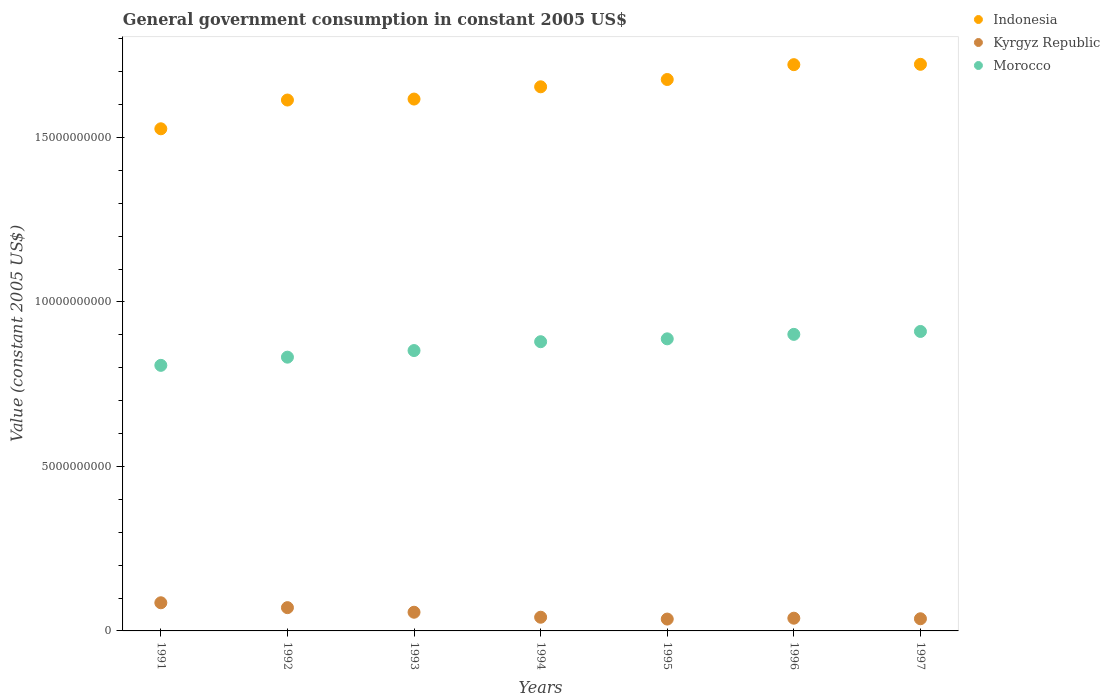What is the government conusmption in Indonesia in 1994?
Your answer should be very brief. 1.65e+1. Across all years, what is the maximum government conusmption in Indonesia?
Your answer should be very brief. 1.72e+1. Across all years, what is the minimum government conusmption in Morocco?
Give a very brief answer. 8.07e+09. In which year was the government conusmption in Indonesia minimum?
Offer a terse response. 1991. What is the total government conusmption in Indonesia in the graph?
Give a very brief answer. 1.15e+11. What is the difference between the government conusmption in Indonesia in 1991 and that in 1997?
Ensure brevity in your answer.  -1.96e+09. What is the difference between the government conusmption in Kyrgyz Republic in 1991 and the government conusmption in Morocco in 1992?
Your response must be concise. -7.47e+09. What is the average government conusmption in Morocco per year?
Your response must be concise. 8.67e+09. In the year 1991, what is the difference between the government conusmption in Indonesia and government conusmption in Morocco?
Your answer should be very brief. 7.19e+09. In how many years, is the government conusmption in Kyrgyz Republic greater than 10000000000 US$?
Your response must be concise. 0. What is the ratio of the government conusmption in Indonesia in 1994 to that in 1996?
Make the answer very short. 0.96. Is the government conusmption in Kyrgyz Republic in 1994 less than that in 1995?
Make the answer very short. No. What is the difference between the highest and the second highest government conusmption in Indonesia?
Your answer should be compact. 1.05e+07. What is the difference between the highest and the lowest government conusmption in Morocco?
Your response must be concise. 1.03e+09. Is the government conusmption in Morocco strictly greater than the government conusmption in Kyrgyz Republic over the years?
Give a very brief answer. Yes. How many years are there in the graph?
Make the answer very short. 7. What is the difference between two consecutive major ticks on the Y-axis?
Your response must be concise. 5.00e+09. Does the graph contain any zero values?
Provide a short and direct response. No. Where does the legend appear in the graph?
Make the answer very short. Top right. What is the title of the graph?
Ensure brevity in your answer.  General government consumption in constant 2005 US$. What is the label or title of the Y-axis?
Your answer should be compact. Value (constant 2005 US$). What is the Value (constant 2005 US$) of Indonesia in 1991?
Keep it short and to the point. 1.53e+1. What is the Value (constant 2005 US$) of Kyrgyz Republic in 1991?
Make the answer very short. 8.56e+08. What is the Value (constant 2005 US$) in Morocco in 1991?
Offer a terse response. 8.07e+09. What is the Value (constant 2005 US$) of Indonesia in 1992?
Your response must be concise. 1.61e+1. What is the Value (constant 2005 US$) of Kyrgyz Republic in 1992?
Ensure brevity in your answer.  7.08e+08. What is the Value (constant 2005 US$) in Morocco in 1992?
Offer a very short reply. 8.32e+09. What is the Value (constant 2005 US$) of Indonesia in 1993?
Your answer should be compact. 1.62e+1. What is the Value (constant 2005 US$) of Kyrgyz Republic in 1993?
Your answer should be very brief. 5.68e+08. What is the Value (constant 2005 US$) of Morocco in 1993?
Keep it short and to the point. 8.52e+09. What is the Value (constant 2005 US$) of Indonesia in 1994?
Offer a terse response. 1.65e+1. What is the Value (constant 2005 US$) in Kyrgyz Republic in 1994?
Provide a succinct answer. 4.16e+08. What is the Value (constant 2005 US$) in Morocco in 1994?
Ensure brevity in your answer.  8.79e+09. What is the Value (constant 2005 US$) of Indonesia in 1995?
Ensure brevity in your answer.  1.68e+1. What is the Value (constant 2005 US$) of Kyrgyz Republic in 1995?
Give a very brief answer. 3.60e+08. What is the Value (constant 2005 US$) in Morocco in 1995?
Your response must be concise. 8.88e+09. What is the Value (constant 2005 US$) of Indonesia in 1996?
Give a very brief answer. 1.72e+1. What is the Value (constant 2005 US$) of Kyrgyz Republic in 1996?
Provide a short and direct response. 3.87e+08. What is the Value (constant 2005 US$) of Morocco in 1996?
Ensure brevity in your answer.  9.02e+09. What is the Value (constant 2005 US$) in Indonesia in 1997?
Provide a succinct answer. 1.72e+1. What is the Value (constant 2005 US$) in Kyrgyz Republic in 1997?
Give a very brief answer. 3.70e+08. What is the Value (constant 2005 US$) in Morocco in 1997?
Your answer should be compact. 9.10e+09. Across all years, what is the maximum Value (constant 2005 US$) of Indonesia?
Your answer should be compact. 1.72e+1. Across all years, what is the maximum Value (constant 2005 US$) of Kyrgyz Republic?
Ensure brevity in your answer.  8.56e+08. Across all years, what is the maximum Value (constant 2005 US$) of Morocco?
Provide a succinct answer. 9.10e+09. Across all years, what is the minimum Value (constant 2005 US$) of Indonesia?
Make the answer very short. 1.53e+1. Across all years, what is the minimum Value (constant 2005 US$) in Kyrgyz Republic?
Provide a succinct answer. 3.60e+08. Across all years, what is the minimum Value (constant 2005 US$) in Morocco?
Your response must be concise. 8.07e+09. What is the total Value (constant 2005 US$) of Indonesia in the graph?
Make the answer very short. 1.15e+11. What is the total Value (constant 2005 US$) in Kyrgyz Republic in the graph?
Make the answer very short. 3.66e+09. What is the total Value (constant 2005 US$) of Morocco in the graph?
Give a very brief answer. 6.07e+1. What is the difference between the Value (constant 2005 US$) of Indonesia in 1991 and that in 1992?
Give a very brief answer. -8.74e+08. What is the difference between the Value (constant 2005 US$) of Kyrgyz Republic in 1991 and that in 1992?
Your answer should be compact. 1.48e+08. What is the difference between the Value (constant 2005 US$) in Morocco in 1991 and that in 1992?
Your response must be concise. -2.49e+08. What is the difference between the Value (constant 2005 US$) of Indonesia in 1991 and that in 1993?
Your answer should be compact. -9.04e+08. What is the difference between the Value (constant 2005 US$) in Kyrgyz Republic in 1991 and that in 1993?
Ensure brevity in your answer.  2.88e+08. What is the difference between the Value (constant 2005 US$) of Morocco in 1991 and that in 1993?
Provide a short and direct response. -4.50e+08. What is the difference between the Value (constant 2005 US$) of Indonesia in 1991 and that in 1994?
Keep it short and to the point. -1.28e+09. What is the difference between the Value (constant 2005 US$) in Kyrgyz Republic in 1991 and that in 1994?
Provide a succinct answer. 4.40e+08. What is the difference between the Value (constant 2005 US$) of Morocco in 1991 and that in 1994?
Ensure brevity in your answer.  -7.19e+08. What is the difference between the Value (constant 2005 US$) in Indonesia in 1991 and that in 1995?
Keep it short and to the point. -1.50e+09. What is the difference between the Value (constant 2005 US$) in Kyrgyz Republic in 1991 and that in 1995?
Your answer should be compact. 4.95e+08. What is the difference between the Value (constant 2005 US$) of Morocco in 1991 and that in 1995?
Offer a terse response. -8.06e+08. What is the difference between the Value (constant 2005 US$) of Indonesia in 1991 and that in 1996?
Keep it short and to the point. -1.95e+09. What is the difference between the Value (constant 2005 US$) of Kyrgyz Republic in 1991 and that in 1996?
Provide a succinct answer. 4.69e+08. What is the difference between the Value (constant 2005 US$) in Morocco in 1991 and that in 1996?
Provide a short and direct response. -9.42e+08. What is the difference between the Value (constant 2005 US$) of Indonesia in 1991 and that in 1997?
Your answer should be very brief. -1.96e+09. What is the difference between the Value (constant 2005 US$) in Kyrgyz Republic in 1991 and that in 1997?
Your answer should be very brief. 4.86e+08. What is the difference between the Value (constant 2005 US$) of Morocco in 1991 and that in 1997?
Make the answer very short. -1.03e+09. What is the difference between the Value (constant 2005 US$) in Indonesia in 1992 and that in 1993?
Make the answer very short. -2.95e+07. What is the difference between the Value (constant 2005 US$) in Kyrgyz Republic in 1992 and that in 1993?
Ensure brevity in your answer.  1.39e+08. What is the difference between the Value (constant 2005 US$) of Morocco in 1992 and that in 1993?
Offer a terse response. -2.01e+08. What is the difference between the Value (constant 2005 US$) in Indonesia in 1992 and that in 1994?
Keep it short and to the point. -4.02e+08. What is the difference between the Value (constant 2005 US$) in Kyrgyz Republic in 1992 and that in 1994?
Provide a short and direct response. 2.91e+08. What is the difference between the Value (constant 2005 US$) in Morocco in 1992 and that in 1994?
Make the answer very short. -4.70e+08. What is the difference between the Value (constant 2005 US$) in Indonesia in 1992 and that in 1995?
Keep it short and to the point. -6.24e+08. What is the difference between the Value (constant 2005 US$) in Kyrgyz Republic in 1992 and that in 1995?
Ensure brevity in your answer.  3.47e+08. What is the difference between the Value (constant 2005 US$) of Morocco in 1992 and that in 1995?
Your answer should be compact. -5.57e+08. What is the difference between the Value (constant 2005 US$) in Indonesia in 1992 and that in 1996?
Provide a short and direct response. -1.08e+09. What is the difference between the Value (constant 2005 US$) in Kyrgyz Republic in 1992 and that in 1996?
Give a very brief answer. 3.21e+08. What is the difference between the Value (constant 2005 US$) of Morocco in 1992 and that in 1996?
Make the answer very short. -6.93e+08. What is the difference between the Value (constant 2005 US$) of Indonesia in 1992 and that in 1997?
Make the answer very short. -1.09e+09. What is the difference between the Value (constant 2005 US$) in Kyrgyz Republic in 1992 and that in 1997?
Offer a very short reply. 3.38e+08. What is the difference between the Value (constant 2005 US$) of Morocco in 1992 and that in 1997?
Your answer should be compact. -7.82e+08. What is the difference between the Value (constant 2005 US$) of Indonesia in 1993 and that in 1994?
Provide a short and direct response. -3.73e+08. What is the difference between the Value (constant 2005 US$) of Kyrgyz Republic in 1993 and that in 1994?
Your response must be concise. 1.52e+08. What is the difference between the Value (constant 2005 US$) in Morocco in 1993 and that in 1994?
Ensure brevity in your answer.  -2.69e+08. What is the difference between the Value (constant 2005 US$) of Indonesia in 1993 and that in 1995?
Keep it short and to the point. -5.95e+08. What is the difference between the Value (constant 2005 US$) in Kyrgyz Republic in 1993 and that in 1995?
Provide a short and direct response. 2.08e+08. What is the difference between the Value (constant 2005 US$) in Morocco in 1993 and that in 1995?
Offer a terse response. -3.56e+08. What is the difference between the Value (constant 2005 US$) in Indonesia in 1993 and that in 1996?
Keep it short and to the point. -1.05e+09. What is the difference between the Value (constant 2005 US$) in Kyrgyz Republic in 1993 and that in 1996?
Your answer should be very brief. 1.81e+08. What is the difference between the Value (constant 2005 US$) in Morocco in 1993 and that in 1996?
Your answer should be very brief. -4.92e+08. What is the difference between the Value (constant 2005 US$) of Indonesia in 1993 and that in 1997?
Make the answer very short. -1.06e+09. What is the difference between the Value (constant 2005 US$) of Kyrgyz Republic in 1993 and that in 1997?
Ensure brevity in your answer.  1.99e+08. What is the difference between the Value (constant 2005 US$) in Morocco in 1993 and that in 1997?
Give a very brief answer. -5.81e+08. What is the difference between the Value (constant 2005 US$) in Indonesia in 1994 and that in 1995?
Your answer should be very brief. -2.22e+08. What is the difference between the Value (constant 2005 US$) in Kyrgyz Republic in 1994 and that in 1995?
Ensure brevity in your answer.  5.59e+07. What is the difference between the Value (constant 2005 US$) in Morocco in 1994 and that in 1995?
Provide a short and direct response. -8.72e+07. What is the difference between the Value (constant 2005 US$) of Indonesia in 1994 and that in 1996?
Ensure brevity in your answer.  -6.73e+08. What is the difference between the Value (constant 2005 US$) of Kyrgyz Republic in 1994 and that in 1996?
Keep it short and to the point. 2.95e+07. What is the difference between the Value (constant 2005 US$) of Morocco in 1994 and that in 1996?
Make the answer very short. -2.23e+08. What is the difference between the Value (constant 2005 US$) in Indonesia in 1994 and that in 1997?
Your answer should be very brief. -6.84e+08. What is the difference between the Value (constant 2005 US$) in Kyrgyz Republic in 1994 and that in 1997?
Give a very brief answer. 4.68e+07. What is the difference between the Value (constant 2005 US$) in Morocco in 1994 and that in 1997?
Offer a very short reply. -3.12e+08. What is the difference between the Value (constant 2005 US$) of Indonesia in 1995 and that in 1996?
Your answer should be very brief. -4.51e+08. What is the difference between the Value (constant 2005 US$) of Kyrgyz Republic in 1995 and that in 1996?
Ensure brevity in your answer.  -2.63e+07. What is the difference between the Value (constant 2005 US$) in Morocco in 1995 and that in 1996?
Ensure brevity in your answer.  -1.36e+08. What is the difference between the Value (constant 2005 US$) of Indonesia in 1995 and that in 1997?
Your answer should be very brief. -4.62e+08. What is the difference between the Value (constant 2005 US$) of Kyrgyz Republic in 1995 and that in 1997?
Provide a short and direct response. -9.12e+06. What is the difference between the Value (constant 2005 US$) of Morocco in 1995 and that in 1997?
Ensure brevity in your answer.  -2.24e+08. What is the difference between the Value (constant 2005 US$) in Indonesia in 1996 and that in 1997?
Offer a very short reply. -1.05e+07. What is the difference between the Value (constant 2005 US$) of Kyrgyz Republic in 1996 and that in 1997?
Ensure brevity in your answer.  1.72e+07. What is the difference between the Value (constant 2005 US$) in Morocco in 1996 and that in 1997?
Offer a very short reply. -8.85e+07. What is the difference between the Value (constant 2005 US$) in Indonesia in 1991 and the Value (constant 2005 US$) in Kyrgyz Republic in 1992?
Offer a terse response. 1.46e+1. What is the difference between the Value (constant 2005 US$) of Indonesia in 1991 and the Value (constant 2005 US$) of Morocco in 1992?
Give a very brief answer. 6.94e+09. What is the difference between the Value (constant 2005 US$) in Kyrgyz Republic in 1991 and the Value (constant 2005 US$) in Morocco in 1992?
Keep it short and to the point. -7.47e+09. What is the difference between the Value (constant 2005 US$) of Indonesia in 1991 and the Value (constant 2005 US$) of Kyrgyz Republic in 1993?
Your response must be concise. 1.47e+1. What is the difference between the Value (constant 2005 US$) of Indonesia in 1991 and the Value (constant 2005 US$) of Morocco in 1993?
Provide a succinct answer. 6.74e+09. What is the difference between the Value (constant 2005 US$) in Kyrgyz Republic in 1991 and the Value (constant 2005 US$) in Morocco in 1993?
Give a very brief answer. -7.67e+09. What is the difference between the Value (constant 2005 US$) of Indonesia in 1991 and the Value (constant 2005 US$) of Kyrgyz Republic in 1994?
Your response must be concise. 1.48e+1. What is the difference between the Value (constant 2005 US$) of Indonesia in 1991 and the Value (constant 2005 US$) of Morocco in 1994?
Keep it short and to the point. 6.47e+09. What is the difference between the Value (constant 2005 US$) in Kyrgyz Republic in 1991 and the Value (constant 2005 US$) in Morocco in 1994?
Ensure brevity in your answer.  -7.94e+09. What is the difference between the Value (constant 2005 US$) of Indonesia in 1991 and the Value (constant 2005 US$) of Kyrgyz Republic in 1995?
Make the answer very short. 1.49e+1. What is the difference between the Value (constant 2005 US$) in Indonesia in 1991 and the Value (constant 2005 US$) in Morocco in 1995?
Offer a terse response. 6.39e+09. What is the difference between the Value (constant 2005 US$) in Kyrgyz Republic in 1991 and the Value (constant 2005 US$) in Morocco in 1995?
Provide a short and direct response. -8.02e+09. What is the difference between the Value (constant 2005 US$) of Indonesia in 1991 and the Value (constant 2005 US$) of Kyrgyz Republic in 1996?
Keep it short and to the point. 1.49e+1. What is the difference between the Value (constant 2005 US$) in Indonesia in 1991 and the Value (constant 2005 US$) in Morocco in 1996?
Provide a succinct answer. 6.25e+09. What is the difference between the Value (constant 2005 US$) in Kyrgyz Republic in 1991 and the Value (constant 2005 US$) in Morocco in 1996?
Keep it short and to the point. -8.16e+09. What is the difference between the Value (constant 2005 US$) in Indonesia in 1991 and the Value (constant 2005 US$) in Kyrgyz Republic in 1997?
Your response must be concise. 1.49e+1. What is the difference between the Value (constant 2005 US$) in Indonesia in 1991 and the Value (constant 2005 US$) in Morocco in 1997?
Provide a short and direct response. 6.16e+09. What is the difference between the Value (constant 2005 US$) in Kyrgyz Republic in 1991 and the Value (constant 2005 US$) in Morocco in 1997?
Your answer should be very brief. -8.25e+09. What is the difference between the Value (constant 2005 US$) of Indonesia in 1992 and the Value (constant 2005 US$) of Kyrgyz Republic in 1993?
Offer a very short reply. 1.56e+1. What is the difference between the Value (constant 2005 US$) of Indonesia in 1992 and the Value (constant 2005 US$) of Morocco in 1993?
Offer a terse response. 7.62e+09. What is the difference between the Value (constant 2005 US$) of Kyrgyz Republic in 1992 and the Value (constant 2005 US$) of Morocco in 1993?
Offer a terse response. -7.82e+09. What is the difference between the Value (constant 2005 US$) of Indonesia in 1992 and the Value (constant 2005 US$) of Kyrgyz Republic in 1994?
Keep it short and to the point. 1.57e+1. What is the difference between the Value (constant 2005 US$) of Indonesia in 1992 and the Value (constant 2005 US$) of Morocco in 1994?
Your response must be concise. 7.35e+09. What is the difference between the Value (constant 2005 US$) of Kyrgyz Republic in 1992 and the Value (constant 2005 US$) of Morocco in 1994?
Make the answer very short. -8.09e+09. What is the difference between the Value (constant 2005 US$) of Indonesia in 1992 and the Value (constant 2005 US$) of Kyrgyz Republic in 1995?
Provide a short and direct response. 1.58e+1. What is the difference between the Value (constant 2005 US$) in Indonesia in 1992 and the Value (constant 2005 US$) in Morocco in 1995?
Offer a very short reply. 7.26e+09. What is the difference between the Value (constant 2005 US$) in Kyrgyz Republic in 1992 and the Value (constant 2005 US$) in Morocco in 1995?
Provide a succinct answer. -8.17e+09. What is the difference between the Value (constant 2005 US$) of Indonesia in 1992 and the Value (constant 2005 US$) of Kyrgyz Republic in 1996?
Provide a short and direct response. 1.58e+1. What is the difference between the Value (constant 2005 US$) in Indonesia in 1992 and the Value (constant 2005 US$) in Morocco in 1996?
Your answer should be compact. 7.12e+09. What is the difference between the Value (constant 2005 US$) of Kyrgyz Republic in 1992 and the Value (constant 2005 US$) of Morocco in 1996?
Give a very brief answer. -8.31e+09. What is the difference between the Value (constant 2005 US$) of Indonesia in 1992 and the Value (constant 2005 US$) of Kyrgyz Republic in 1997?
Make the answer very short. 1.58e+1. What is the difference between the Value (constant 2005 US$) of Indonesia in 1992 and the Value (constant 2005 US$) of Morocco in 1997?
Your answer should be very brief. 7.04e+09. What is the difference between the Value (constant 2005 US$) in Kyrgyz Republic in 1992 and the Value (constant 2005 US$) in Morocco in 1997?
Make the answer very short. -8.40e+09. What is the difference between the Value (constant 2005 US$) in Indonesia in 1993 and the Value (constant 2005 US$) in Kyrgyz Republic in 1994?
Your response must be concise. 1.58e+1. What is the difference between the Value (constant 2005 US$) in Indonesia in 1993 and the Value (constant 2005 US$) in Morocco in 1994?
Your answer should be very brief. 7.38e+09. What is the difference between the Value (constant 2005 US$) of Kyrgyz Republic in 1993 and the Value (constant 2005 US$) of Morocco in 1994?
Your response must be concise. -8.22e+09. What is the difference between the Value (constant 2005 US$) in Indonesia in 1993 and the Value (constant 2005 US$) in Kyrgyz Republic in 1995?
Make the answer very short. 1.58e+1. What is the difference between the Value (constant 2005 US$) in Indonesia in 1993 and the Value (constant 2005 US$) in Morocco in 1995?
Provide a succinct answer. 7.29e+09. What is the difference between the Value (constant 2005 US$) in Kyrgyz Republic in 1993 and the Value (constant 2005 US$) in Morocco in 1995?
Offer a very short reply. -8.31e+09. What is the difference between the Value (constant 2005 US$) in Indonesia in 1993 and the Value (constant 2005 US$) in Kyrgyz Republic in 1996?
Ensure brevity in your answer.  1.58e+1. What is the difference between the Value (constant 2005 US$) in Indonesia in 1993 and the Value (constant 2005 US$) in Morocco in 1996?
Give a very brief answer. 7.15e+09. What is the difference between the Value (constant 2005 US$) of Kyrgyz Republic in 1993 and the Value (constant 2005 US$) of Morocco in 1996?
Keep it short and to the point. -8.45e+09. What is the difference between the Value (constant 2005 US$) of Indonesia in 1993 and the Value (constant 2005 US$) of Kyrgyz Republic in 1997?
Give a very brief answer. 1.58e+1. What is the difference between the Value (constant 2005 US$) in Indonesia in 1993 and the Value (constant 2005 US$) in Morocco in 1997?
Your response must be concise. 7.07e+09. What is the difference between the Value (constant 2005 US$) of Kyrgyz Republic in 1993 and the Value (constant 2005 US$) of Morocco in 1997?
Provide a short and direct response. -8.54e+09. What is the difference between the Value (constant 2005 US$) of Indonesia in 1994 and the Value (constant 2005 US$) of Kyrgyz Republic in 1995?
Provide a succinct answer. 1.62e+1. What is the difference between the Value (constant 2005 US$) of Indonesia in 1994 and the Value (constant 2005 US$) of Morocco in 1995?
Offer a terse response. 7.66e+09. What is the difference between the Value (constant 2005 US$) in Kyrgyz Republic in 1994 and the Value (constant 2005 US$) in Morocco in 1995?
Offer a very short reply. -8.46e+09. What is the difference between the Value (constant 2005 US$) of Indonesia in 1994 and the Value (constant 2005 US$) of Kyrgyz Republic in 1996?
Offer a terse response. 1.62e+1. What is the difference between the Value (constant 2005 US$) of Indonesia in 1994 and the Value (constant 2005 US$) of Morocco in 1996?
Make the answer very short. 7.53e+09. What is the difference between the Value (constant 2005 US$) of Kyrgyz Republic in 1994 and the Value (constant 2005 US$) of Morocco in 1996?
Provide a short and direct response. -8.60e+09. What is the difference between the Value (constant 2005 US$) of Indonesia in 1994 and the Value (constant 2005 US$) of Kyrgyz Republic in 1997?
Ensure brevity in your answer.  1.62e+1. What is the difference between the Value (constant 2005 US$) of Indonesia in 1994 and the Value (constant 2005 US$) of Morocco in 1997?
Offer a very short reply. 7.44e+09. What is the difference between the Value (constant 2005 US$) of Kyrgyz Republic in 1994 and the Value (constant 2005 US$) of Morocco in 1997?
Offer a very short reply. -8.69e+09. What is the difference between the Value (constant 2005 US$) in Indonesia in 1995 and the Value (constant 2005 US$) in Kyrgyz Republic in 1996?
Keep it short and to the point. 1.64e+1. What is the difference between the Value (constant 2005 US$) in Indonesia in 1995 and the Value (constant 2005 US$) in Morocco in 1996?
Your answer should be compact. 7.75e+09. What is the difference between the Value (constant 2005 US$) of Kyrgyz Republic in 1995 and the Value (constant 2005 US$) of Morocco in 1996?
Provide a short and direct response. -8.66e+09. What is the difference between the Value (constant 2005 US$) of Indonesia in 1995 and the Value (constant 2005 US$) of Kyrgyz Republic in 1997?
Ensure brevity in your answer.  1.64e+1. What is the difference between the Value (constant 2005 US$) in Indonesia in 1995 and the Value (constant 2005 US$) in Morocco in 1997?
Your answer should be compact. 7.66e+09. What is the difference between the Value (constant 2005 US$) in Kyrgyz Republic in 1995 and the Value (constant 2005 US$) in Morocco in 1997?
Keep it short and to the point. -8.74e+09. What is the difference between the Value (constant 2005 US$) in Indonesia in 1996 and the Value (constant 2005 US$) in Kyrgyz Republic in 1997?
Offer a very short reply. 1.68e+1. What is the difference between the Value (constant 2005 US$) of Indonesia in 1996 and the Value (constant 2005 US$) of Morocco in 1997?
Offer a very short reply. 8.11e+09. What is the difference between the Value (constant 2005 US$) of Kyrgyz Republic in 1996 and the Value (constant 2005 US$) of Morocco in 1997?
Offer a very short reply. -8.72e+09. What is the average Value (constant 2005 US$) in Indonesia per year?
Give a very brief answer. 1.65e+1. What is the average Value (constant 2005 US$) of Kyrgyz Republic per year?
Offer a terse response. 5.24e+08. What is the average Value (constant 2005 US$) in Morocco per year?
Offer a very short reply. 8.67e+09. In the year 1991, what is the difference between the Value (constant 2005 US$) in Indonesia and Value (constant 2005 US$) in Kyrgyz Republic?
Offer a terse response. 1.44e+1. In the year 1991, what is the difference between the Value (constant 2005 US$) in Indonesia and Value (constant 2005 US$) in Morocco?
Your response must be concise. 7.19e+09. In the year 1991, what is the difference between the Value (constant 2005 US$) of Kyrgyz Republic and Value (constant 2005 US$) of Morocco?
Your answer should be compact. -7.22e+09. In the year 1992, what is the difference between the Value (constant 2005 US$) of Indonesia and Value (constant 2005 US$) of Kyrgyz Republic?
Your answer should be compact. 1.54e+1. In the year 1992, what is the difference between the Value (constant 2005 US$) of Indonesia and Value (constant 2005 US$) of Morocco?
Offer a very short reply. 7.82e+09. In the year 1992, what is the difference between the Value (constant 2005 US$) in Kyrgyz Republic and Value (constant 2005 US$) in Morocco?
Offer a very short reply. -7.62e+09. In the year 1993, what is the difference between the Value (constant 2005 US$) in Indonesia and Value (constant 2005 US$) in Kyrgyz Republic?
Provide a short and direct response. 1.56e+1. In the year 1993, what is the difference between the Value (constant 2005 US$) in Indonesia and Value (constant 2005 US$) in Morocco?
Your response must be concise. 7.65e+09. In the year 1993, what is the difference between the Value (constant 2005 US$) in Kyrgyz Republic and Value (constant 2005 US$) in Morocco?
Provide a short and direct response. -7.96e+09. In the year 1994, what is the difference between the Value (constant 2005 US$) in Indonesia and Value (constant 2005 US$) in Kyrgyz Republic?
Provide a succinct answer. 1.61e+1. In the year 1994, what is the difference between the Value (constant 2005 US$) of Indonesia and Value (constant 2005 US$) of Morocco?
Your answer should be compact. 7.75e+09. In the year 1994, what is the difference between the Value (constant 2005 US$) of Kyrgyz Republic and Value (constant 2005 US$) of Morocco?
Provide a succinct answer. -8.38e+09. In the year 1995, what is the difference between the Value (constant 2005 US$) of Indonesia and Value (constant 2005 US$) of Kyrgyz Republic?
Your response must be concise. 1.64e+1. In the year 1995, what is the difference between the Value (constant 2005 US$) in Indonesia and Value (constant 2005 US$) in Morocco?
Your answer should be compact. 7.88e+09. In the year 1995, what is the difference between the Value (constant 2005 US$) in Kyrgyz Republic and Value (constant 2005 US$) in Morocco?
Keep it short and to the point. -8.52e+09. In the year 1996, what is the difference between the Value (constant 2005 US$) of Indonesia and Value (constant 2005 US$) of Kyrgyz Republic?
Offer a terse response. 1.68e+1. In the year 1996, what is the difference between the Value (constant 2005 US$) of Indonesia and Value (constant 2005 US$) of Morocco?
Your answer should be compact. 8.20e+09. In the year 1996, what is the difference between the Value (constant 2005 US$) in Kyrgyz Republic and Value (constant 2005 US$) in Morocco?
Your response must be concise. -8.63e+09. In the year 1997, what is the difference between the Value (constant 2005 US$) of Indonesia and Value (constant 2005 US$) of Kyrgyz Republic?
Provide a succinct answer. 1.69e+1. In the year 1997, what is the difference between the Value (constant 2005 US$) in Indonesia and Value (constant 2005 US$) in Morocco?
Give a very brief answer. 8.12e+09. In the year 1997, what is the difference between the Value (constant 2005 US$) in Kyrgyz Republic and Value (constant 2005 US$) in Morocco?
Ensure brevity in your answer.  -8.73e+09. What is the ratio of the Value (constant 2005 US$) in Indonesia in 1991 to that in 1992?
Your response must be concise. 0.95. What is the ratio of the Value (constant 2005 US$) of Kyrgyz Republic in 1991 to that in 1992?
Make the answer very short. 1.21. What is the ratio of the Value (constant 2005 US$) in Morocco in 1991 to that in 1992?
Your answer should be very brief. 0.97. What is the ratio of the Value (constant 2005 US$) of Indonesia in 1991 to that in 1993?
Offer a terse response. 0.94. What is the ratio of the Value (constant 2005 US$) in Kyrgyz Republic in 1991 to that in 1993?
Provide a succinct answer. 1.51. What is the ratio of the Value (constant 2005 US$) of Morocco in 1991 to that in 1993?
Provide a short and direct response. 0.95. What is the ratio of the Value (constant 2005 US$) in Indonesia in 1991 to that in 1994?
Offer a terse response. 0.92. What is the ratio of the Value (constant 2005 US$) of Kyrgyz Republic in 1991 to that in 1994?
Give a very brief answer. 2.06. What is the ratio of the Value (constant 2005 US$) of Morocco in 1991 to that in 1994?
Keep it short and to the point. 0.92. What is the ratio of the Value (constant 2005 US$) of Indonesia in 1991 to that in 1995?
Make the answer very short. 0.91. What is the ratio of the Value (constant 2005 US$) in Kyrgyz Republic in 1991 to that in 1995?
Your answer should be compact. 2.37. What is the ratio of the Value (constant 2005 US$) of Morocco in 1991 to that in 1995?
Provide a short and direct response. 0.91. What is the ratio of the Value (constant 2005 US$) in Indonesia in 1991 to that in 1996?
Your answer should be compact. 0.89. What is the ratio of the Value (constant 2005 US$) in Kyrgyz Republic in 1991 to that in 1996?
Your answer should be very brief. 2.21. What is the ratio of the Value (constant 2005 US$) of Morocco in 1991 to that in 1996?
Offer a terse response. 0.9. What is the ratio of the Value (constant 2005 US$) of Indonesia in 1991 to that in 1997?
Ensure brevity in your answer.  0.89. What is the ratio of the Value (constant 2005 US$) of Kyrgyz Republic in 1991 to that in 1997?
Ensure brevity in your answer.  2.32. What is the ratio of the Value (constant 2005 US$) of Morocco in 1991 to that in 1997?
Make the answer very short. 0.89. What is the ratio of the Value (constant 2005 US$) in Indonesia in 1992 to that in 1993?
Keep it short and to the point. 1. What is the ratio of the Value (constant 2005 US$) of Kyrgyz Republic in 1992 to that in 1993?
Offer a very short reply. 1.25. What is the ratio of the Value (constant 2005 US$) in Morocco in 1992 to that in 1993?
Ensure brevity in your answer.  0.98. What is the ratio of the Value (constant 2005 US$) of Indonesia in 1992 to that in 1994?
Give a very brief answer. 0.98. What is the ratio of the Value (constant 2005 US$) of Kyrgyz Republic in 1992 to that in 1994?
Your answer should be very brief. 1.7. What is the ratio of the Value (constant 2005 US$) in Morocco in 1992 to that in 1994?
Offer a terse response. 0.95. What is the ratio of the Value (constant 2005 US$) in Indonesia in 1992 to that in 1995?
Give a very brief answer. 0.96. What is the ratio of the Value (constant 2005 US$) of Kyrgyz Republic in 1992 to that in 1995?
Your answer should be compact. 1.96. What is the ratio of the Value (constant 2005 US$) in Morocco in 1992 to that in 1995?
Keep it short and to the point. 0.94. What is the ratio of the Value (constant 2005 US$) in Kyrgyz Republic in 1992 to that in 1996?
Your answer should be compact. 1.83. What is the ratio of the Value (constant 2005 US$) in Morocco in 1992 to that in 1996?
Your response must be concise. 0.92. What is the ratio of the Value (constant 2005 US$) in Indonesia in 1992 to that in 1997?
Make the answer very short. 0.94. What is the ratio of the Value (constant 2005 US$) of Kyrgyz Republic in 1992 to that in 1997?
Your response must be concise. 1.91. What is the ratio of the Value (constant 2005 US$) in Morocco in 1992 to that in 1997?
Your answer should be very brief. 0.91. What is the ratio of the Value (constant 2005 US$) of Indonesia in 1993 to that in 1994?
Your response must be concise. 0.98. What is the ratio of the Value (constant 2005 US$) in Kyrgyz Republic in 1993 to that in 1994?
Your answer should be very brief. 1.36. What is the ratio of the Value (constant 2005 US$) in Morocco in 1993 to that in 1994?
Give a very brief answer. 0.97. What is the ratio of the Value (constant 2005 US$) in Indonesia in 1993 to that in 1995?
Make the answer very short. 0.96. What is the ratio of the Value (constant 2005 US$) in Kyrgyz Republic in 1993 to that in 1995?
Provide a short and direct response. 1.58. What is the ratio of the Value (constant 2005 US$) of Morocco in 1993 to that in 1995?
Keep it short and to the point. 0.96. What is the ratio of the Value (constant 2005 US$) in Indonesia in 1993 to that in 1996?
Make the answer very short. 0.94. What is the ratio of the Value (constant 2005 US$) in Kyrgyz Republic in 1993 to that in 1996?
Offer a very short reply. 1.47. What is the ratio of the Value (constant 2005 US$) of Morocco in 1993 to that in 1996?
Provide a succinct answer. 0.95. What is the ratio of the Value (constant 2005 US$) in Indonesia in 1993 to that in 1997?
Your answer should be very brief. 0.94. What is the ratio of the Value (constant 2005 US$) of Kyrgyz Republic in 1993 to that in 1997?
Offer a terse response. 1.54. What is the ratio of the Value (constant 2005 US$) of Morocco in 1993 to that in 1997?
Make the answer very short. 0.94. What is the ratio of the Value (constant 2005 US$) in Kyrgyz Republic in 1994 to that in 1995?
Offer a very short reply. 1.16. What is the ratio of the Value (constant 2005 US$) in Morocco in 1994 to that in 1995?
Offer a very short reply. 0.99. What is the ratio of the Value (constant 2005 US$) of Indonesia in 1994 to that in 1996?
Provide a succinct answer. 0.96. What is the ratio of the Value (constant 2005 US$) of Kyrgyz Republic in 1994 to that in 1996?
Provide a short and direct response. 1.08. What is the ratio of the Value (constant 2005 US$) in Morocco in 1994 to that in 1996?
Provide a short and direct response. 0.98. What is the ratio of the Value (constant 2005 US$) of Indonesia in 1994 to that in 1997?
Your answer should be compact. 0.96. What is the ratio of the Value (constant 2005 US$) of Kyrgyz Republic in 1994 to that in 1997?
Make the answer very short. 1.13. What is the ratio of the Value (constant 2005 US$) in Morocco in 1994 to that in 1997?
Offer a very short reply. 0.97. What is the ratio of the Value (constant 2005 US$) in Indonesia in 1995 to that in 1996?
Offer a very short reply. 0.97. What is the ratio of the Value (constant 2005 US$) of Kyrgyz Republic in 1995 to that in 1996?
Your answer should be compact. 0.93. What is the ratio of the Value (constant 2005 US$) of Morocco in 1995 to that in 1996?
Ensure brevity in your answer.  0.98. What is the ratio of the Value (constant 2005 US$) of Indonesia in 1995 to that in 1997?
Offer a very short reply. 0.97. What is the ratio of the Value (constant 2005 US$) of Kyrgyz Republic in 1995 to that in 1997?
Make the answer very short. 0.98. What is the ratio of the Value (constant 2005 US$) in Morocco in 1995 to that in 1997?
Offer a terse response. 0.98. What is the ratio of the Value (constant 2005 US$) in Indonesia in 1996 to that in 1997?
Provide a short and direct response. 1. What is the ratio of the Value (constant 2005 US$) of Kyrgyz Republic in 1996 to that in 1997?
Keep it short and to the point. 1.05. What is the ratio of the Value (constant 2005 US$) in Morocco in 1996 to that in 1997?
Make the answer very short. 0.99. What is the difference between the highest and the second highest Value (constant 2005 US$) in Indonesia?
Provide a short and direct response. 1.05e+07. What is the difference between the highest and the second highest Value (constant 2005 US$) in Kyrgyz Republic?
Provide a short and direct response. 1.48e+08. What is the difference between the highest and the second highest Value (constant 2005 US$) of Morocco?
Keep it short and to the point. 8.85e+07. What is the difference between the highest and the lowest Value (constant 2005 US$) of Indonesia?
Offer a very short reply. 1.96e+09. What is the difference between the highest and the lowest Value (constant 2005 US$) of Kyrgyz Republic?
Your response must be concise. 4.95e+08. What is the difference between the highest and the lowest Value (constant 2005 US$) in Morocco?
Make the answer very short. 1.03e+09. 